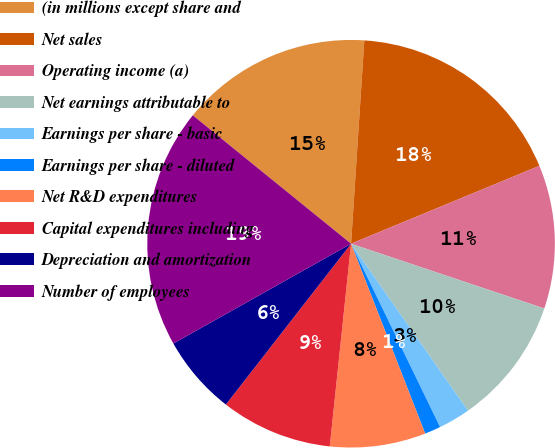Convert chart. <chart><loc_0><loc_0><loc_500><loc_500><pie_chart><fcel>(in millions except share and<fcel>Net sales<fcel>Operating income (a)<fcel>Net earnings attributable to<fcel>Earnings per share - basic<fcel>Earnings per share - diluted<fcel>Net R&D expenditures<fcel>Capital expenditures including<fcel>Depreciation and amortization<fcel>Number of employees<nl><fcel>15.19%<fcel>17.72%<fcel>11.39%<fcel>10.13%<fcel>2.53%<fcel>1.27%<fcel>7.59%<fcel>8.86%<fcel>6.33%<fcel>18.99%<nl></chart> 